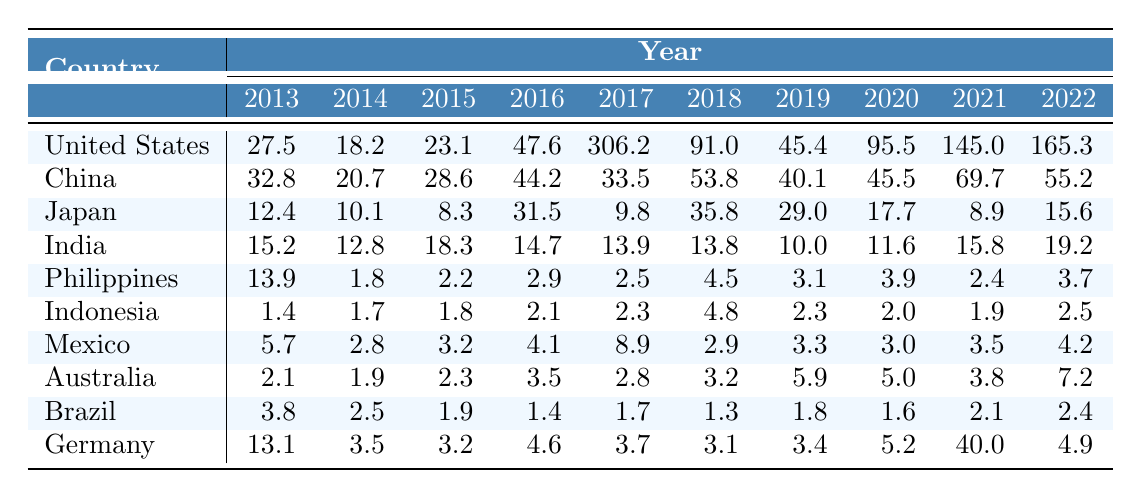What was the maximum economic loss recorded in the United States during the decade? The highest economic loss in the United States occurred in 2017, which is recorded as 306.2.
Answer: 306.2 What country had the lowest economic losses in 2013? In 2013, Indonesia had the lowest economic loss of 1.4.
Answer: 1.4 What is the total economic loss for Japan from 2013 to 2022? The total is calculated by adding the losses for each year: (12.4 + 10.1 + 8.3 + 31.5 + 9.8 + 35.8 + 29.0 + 17.7 + 8.9 + 15.6) =  248.1.
Answer: 248.1 Did the economic losses in China increase every year from 2013 to 2022? No, the losses fluctuated; for example, from 2016 to 2017, there was a decrease in losses (44.2 to 33.5).
Answer: No Which country recorded the highest number of disaster events in 2020? The United States had the highest number of disaster events in 2020, with 42 events.
Answer: United States What is the average economic loss for Brazil over the ten-year period? To calculate the average, sum the losses for Brazil: (3.8 + 2.5 + 1.9 + 1.4 + 1.7 + 1.3 + 1.8 + 1.6 + 2.1 + 2.4) = 20.5, then divide by 10, resulting in an average of 2.05.
Answer: 2.05 What was the total number of disaster events in India between 2016 to 2022? The total number of events is calculated as follows: 31 + 38 + 36 + 34 + 37 + 39 = 215.
Answer: 215 Which country experienced a significant spike in economic losses in 2021? The United States saw a significant spike in losses in 2021 with 145.0, after a smaller loss of 95.5 in 2020.
Answer: United States In which year did the Philippines record the lowest economic loss, and what was that loss? In 2014, the Philippines recorded the lowest economic loss at 1.8.
Answer: 1.8 What was the difference in economic losses between Germany in 2021 and 2022? Germany recorded 40.0 in 2021 and 4.9 in 2022, so the difference is 40.0 - 4.9 = 35.1.
Answer: 35.1 Which country consistently had economic losses below 10 from 2013 to 2020? Both Indonesia and the Philippines had consistent losses below 10 for the given years, with Indonesia having the lowest losses across all years.
Answer: Indonesia, Philippines 